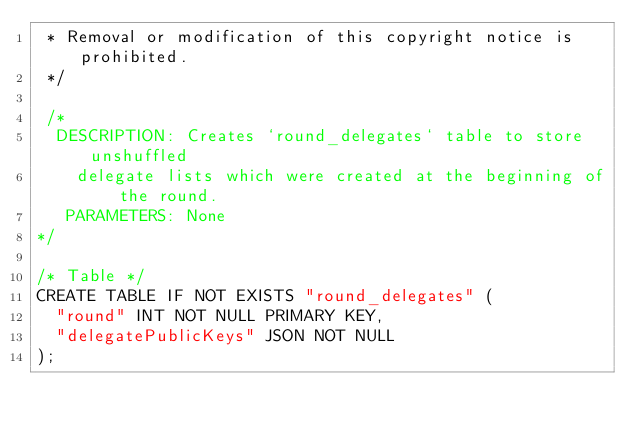<code> <loc_0><loc_0><loc_500><loc_500><_SQL_> * Removal or modification of this copyright notice is prohibited.
 */

 /*
  DESCRIPTION: Creates `round_delegates` table to store unshuffled
	delegate lists which were created at the beginning of the round.
   PARAMETERS: None
*/

/* Table */
CREATE TABLE IF NOT EXISTS "round_delegates" (
  "round" INT NOT NULL PRIMARY KEY,
  "delegatePublicKeys" JSON NOT NULL
);
</code> 